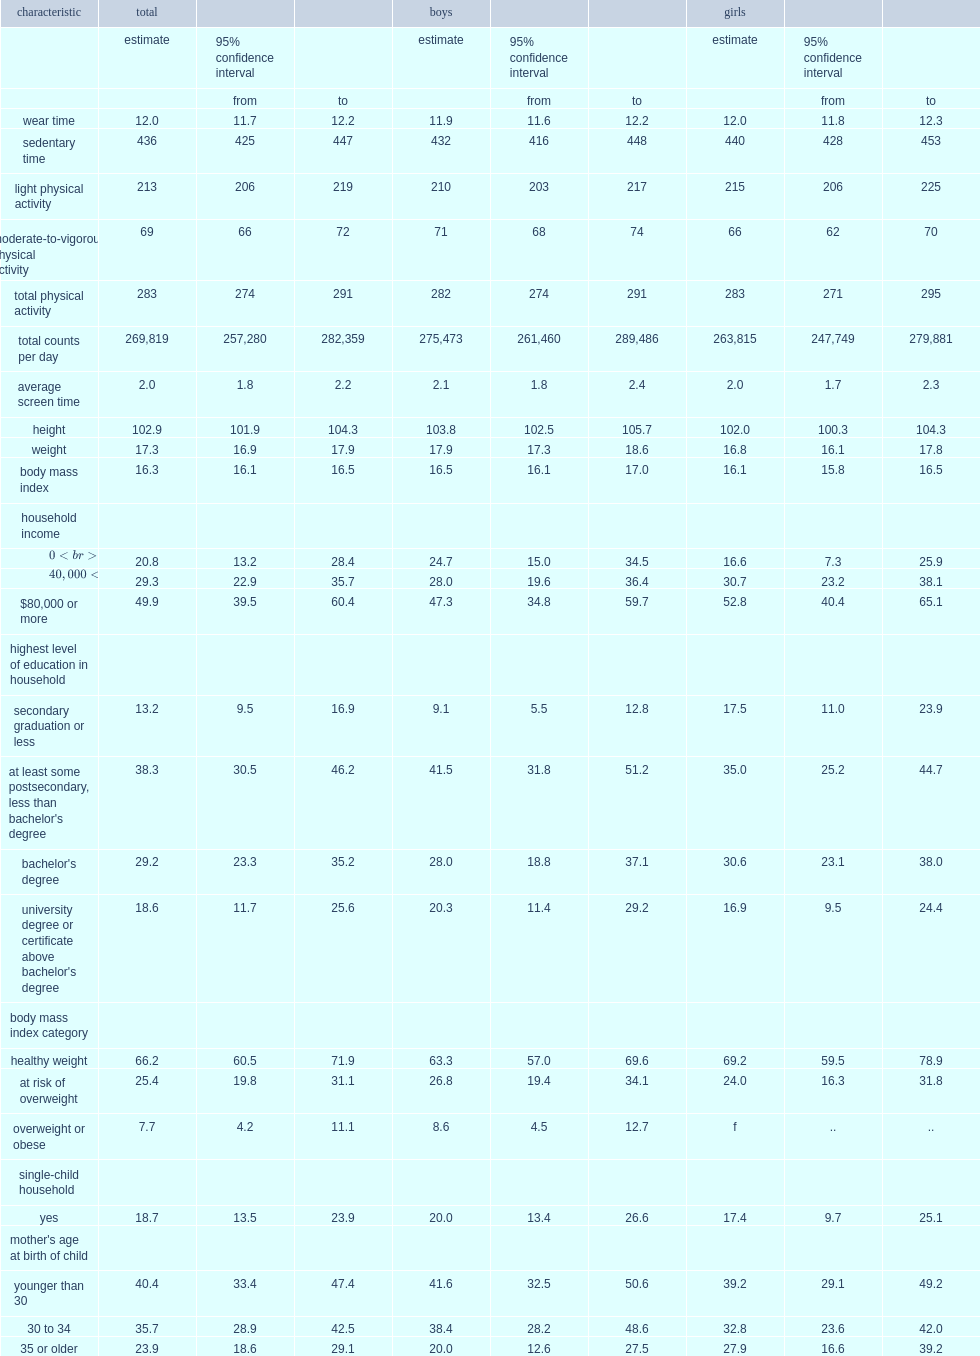How many minutes of physical activity did the total population accumulate per day? 283.0. Of the 283 minutes of physical activity accumulated by total population, how many minutes were mvpa accounted for? 69.0. How many hours did the total three-to-4-year-olds were the accelerometer on valid days? 12.0. On average, how many minutes were the total 3-to-4-year-olds sedentary a day? 436.0. 